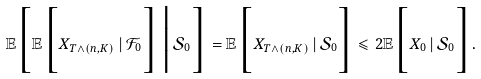<formula> <loc_0><loc_0><loc_500><loc_500>\mathbb { E } \Big [ \mathbb { E } \Big [ X _ { T \wedge ( n , K ) } \, | \, \mathcal { F } _ { 0 } \Big ] \, \Big | \, \mathcal { S } _ { 0 } \Big ] = \mathbb { E } \Big [ X _ { T \wedge ( n , K ) } \, | \, \mathcal { S } _ { 0 } \Big ] \leqslant 2 \mathbb { E } \Big [ X _ { 0 } \, | \, \mathcal { S } _ { 0 } \Big ] .</formula> 